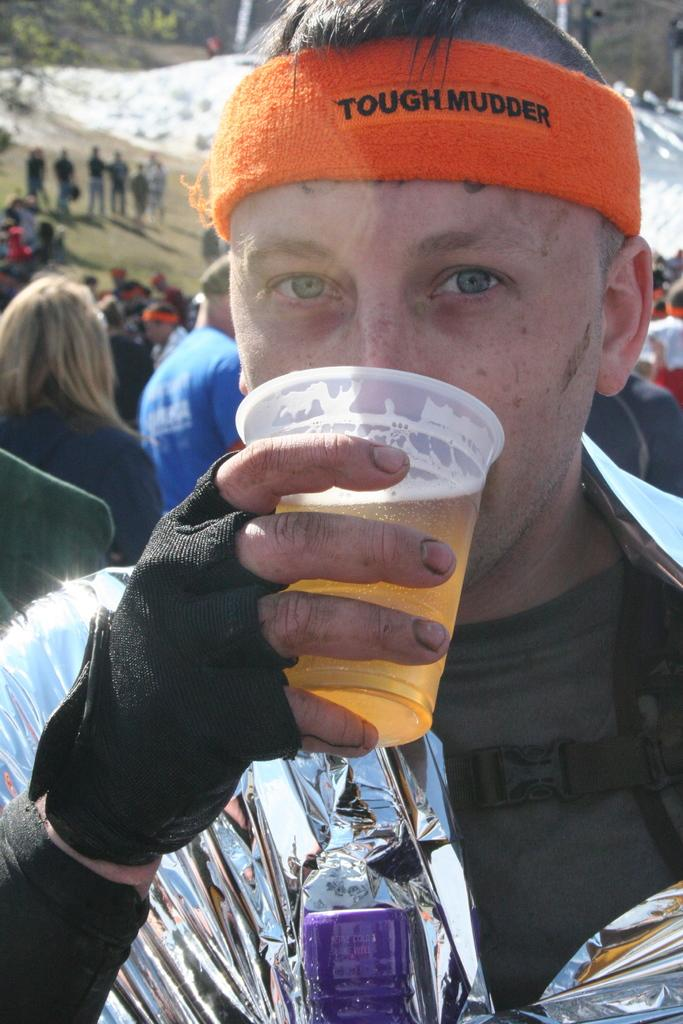Who is the main subject in the image? There is a man in the image. What is the man holding in the image? The man is holding a glass with a drink in it. What is the man doing with the drink? The man is drinking the drink. What can be seen in the background of the image? There are other people and a tree in the background of the image. What type of beef is being served at the store in the image? There is no store or beef present in the image; it features a man drinking from a glass. 